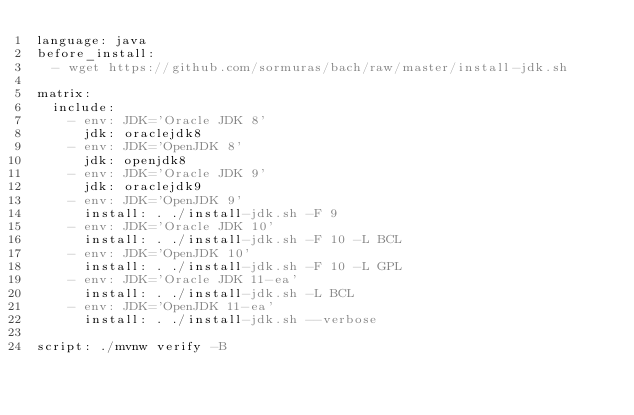Convert code to text. <code><loc_0><loc_0><loc_500><loc_500><_YAML_>language: java
before_install:
  - wget https://github.com/sormuras/bach/raw/master/install-jdk.sh

matrix:
  include:
    - env: JDK='Oracle JDK 8'
      jdk: oraclejdk8
    - env: JDK='OpenJDK 8'
      jdk: openjdk8
    - env: JDK='Oracle JDK 9'
      jdk: oraclejdk9
    - env: JDK='OpenJDK 9'
      install: . ./install-jdk.sh -F 9
    - env: JDK='Oracle JDK 10'
      install: . ./install-jdk.sh -F 10 -L BCL
    - env: JDK='OpenJDK 10'
      install: . ./install-jdk.sh -F 10 -L GPL
    - env: JDK='Oracle JDK 11-ea'
      install: . ./install-jdk.sh -L BCL
    - env: JDK='OpenJDK 11-ea'
      install: . ./install-jdk.sh --verbose

script: ./mvnw verify -B
</code> 